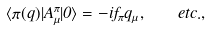Convert formula to latex. <formula><loc_0><loc_0><loc_500><loc_500>\langle \pi ( q ) | A _ { \mu } ^ { \pi } | 0 \rangle = - i f _ { \pi } q _ { \mu } , \quad e t c . ,</formula> 